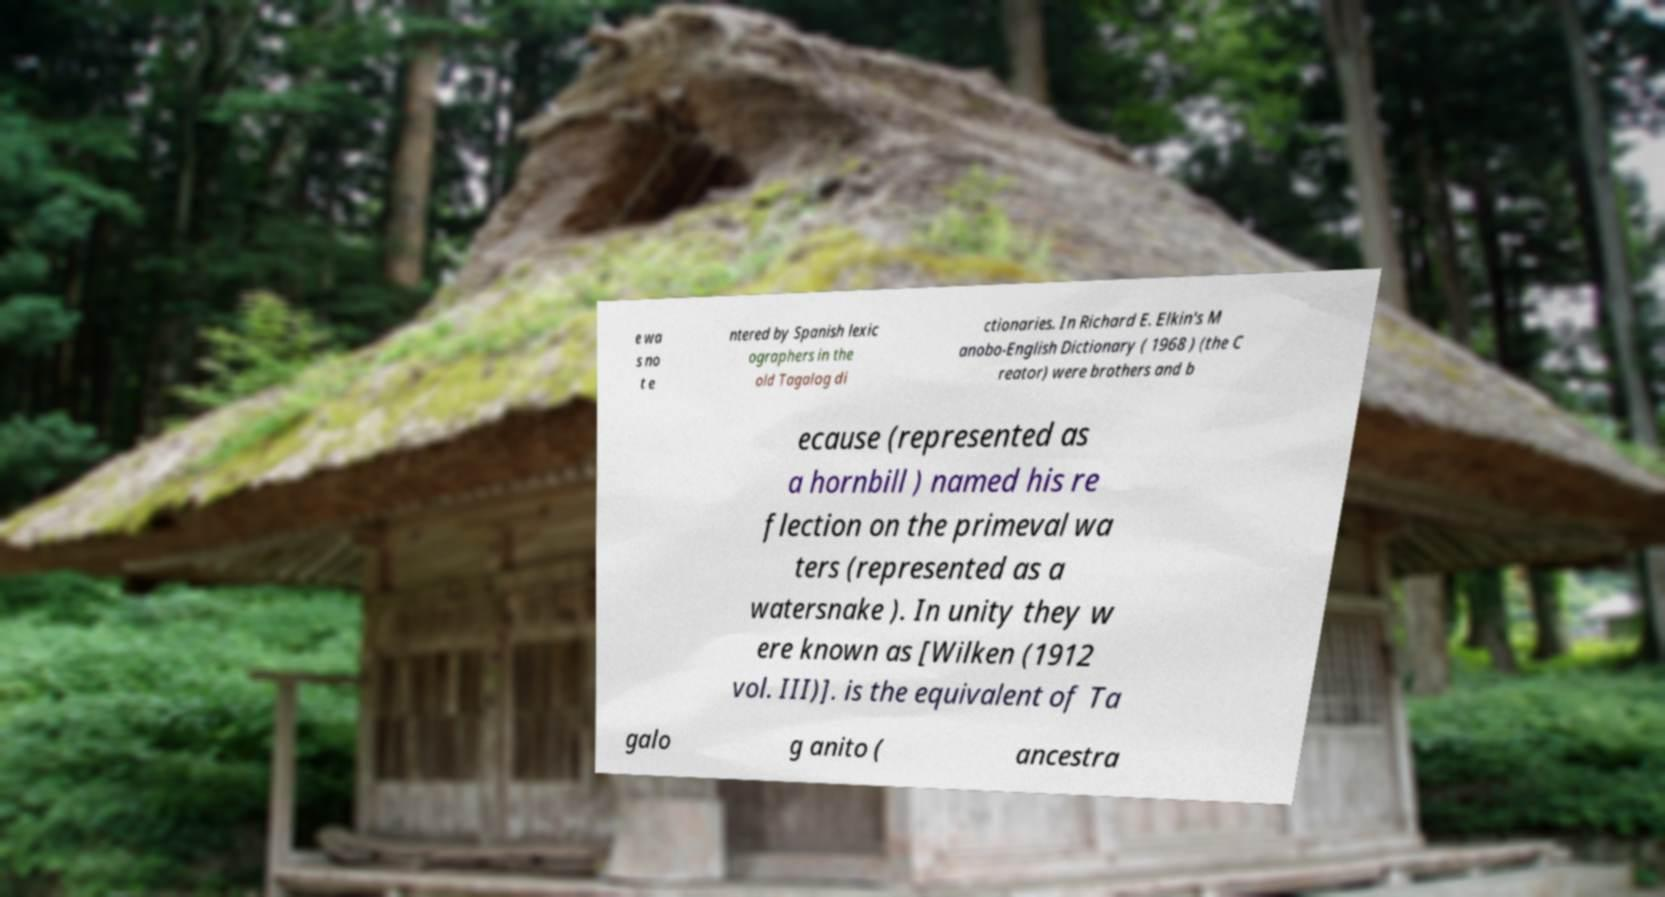For documentation purposes, I need the text within this image transcribed. Could you provide that? e wa s no t e ntered by Spanish lexic ographers in the old Tagalog di ctionaries. In Richard E. Elkin's M anobo-English Dictionary ( 1968 ) (the C reator) were brothers and b ecause (represented as a hornbill ) named his re flection on the primeval wa ters (represented as a watersnake ). In unity they w ere known as [Wilken (1912 vol. III)]. is the equivalent of Ta galo g anito ( ancestra 